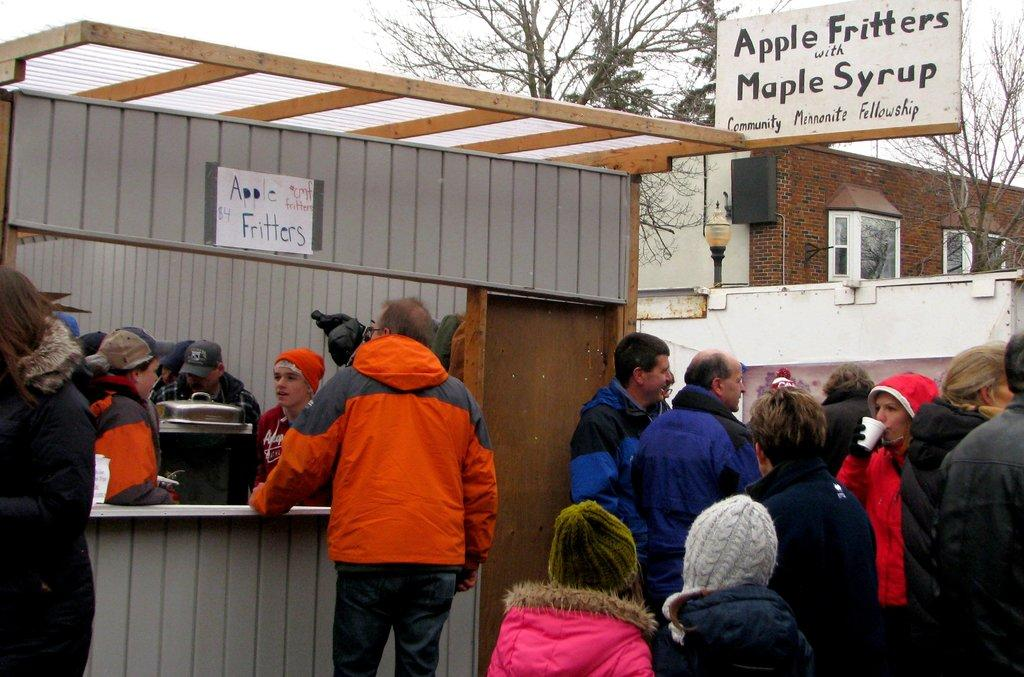How many people can be seen in the image? There are people in the image. What objects are present in the image? There are boards and an object in the image. What type of structure is visible in the image? There is a wall and a door in the image. What can be seen in the background of the image? There is a house, light, windows, trees, and the sky visible in the background of the image. What type of collar is the boy wearing in the image? There is no boy present in the image, and therefore no collar can be observed. 